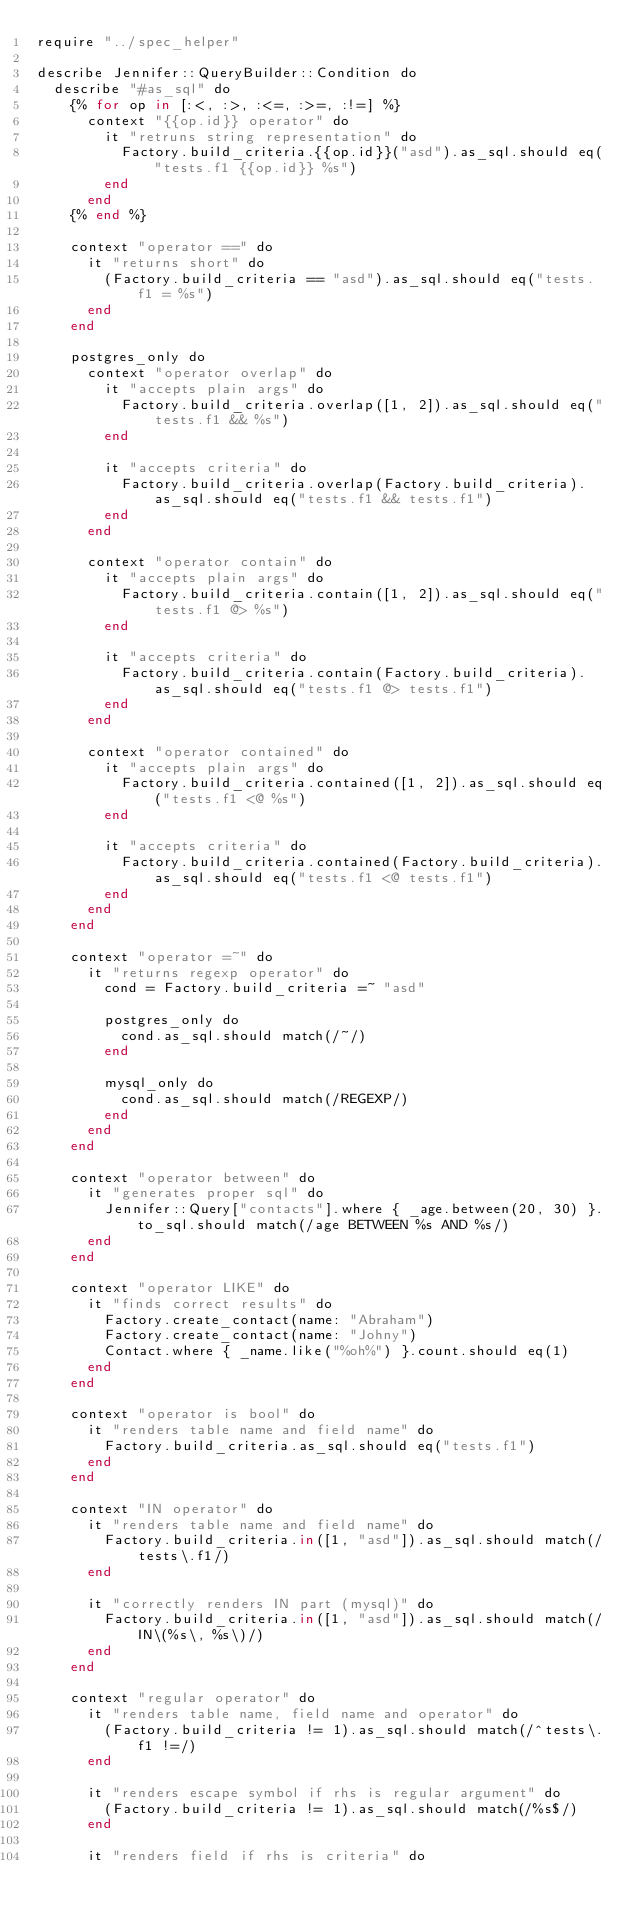<code> <loc_0><loc_0><loc_500><loc_500><_Crystal_>require "../spec_helper"

describe Jennifer::QueryBuilder::Condition do
  describe "#as_sql" do
    {% for op in [:<, :>, :<=, :>=, :!=] %}
      context "{{op.id}} operator" do
        it "retruns string representation" do
          Factory.build_criteria.{{op.id}}("asd").as_sql.should eq("tests.f1 {{op.id}} %s")
        end
      end
    {% end %}

    context "operator ==" do
      it "returns short" do
        (Factory.build_criteria == "asd").as_sql.should eq("tests.f1 = %s")
      end
    end

    postgres_only do
      context "operator overlap" do
        it "accepts plain args" do
          Factory.build_criteria.overlap([1, 2]).as_sql.should eq("tests.f1 && %s")
        end

        it "accepts criteria" do
          Factory.build_criteria.overlap(Factory.build_criteria).as_sql.should eq("tests.f1 && tests.f1")
        end
      end

      context "operator contain" do
        it "accepts plain args" do
          Factory.build_criteria.contain([1, 2]).as_sql.should eq("tests.f1 @> %s")
        end

        it "accepts criteria" do
          Factory.build_criteria.contain(Factory.build_criteria).as_sql.should eq("tests.f1 @> tests.f1")
        end
      end

      context "operator contained" do
        it "accepts plain args" do
          Factory.build_criteria.contained([1, 2]).as_sql.should eq("tests.f1 <@ %s")
        end

        it "accepts criteria" do
          Factory.build_criteria.contained(Factory.build_criteria).as_sql.should eq("tests.f1 <@ tests.f1")
        end
      end
    end

    context "operator =~" do
      it "returns regexp operator" do
        cond = Factory.build_criteria =~ "asd"

        postgres_only do
          cond.as_sql.should match(/~/)
        end

        mysql_only do
          cond.as_sql.should match(/REGEXP/)
        end
      end
    end

    context "operator between" do
      it "generates proper sql" do
        Jennifer::Query["contacts"].where { _age.between(20, 30) }.to_sql.should match(/age BETWEEN %s AND %s/)
      end
    end

    context "operator LIKE" do
      it "finds correct results" do
        Factory.create_contact(name: "Abraham")
        Factory.create_contact(name: "Johny")
        Contact.where { _name.like("%oh%") }.count.should eq(1)
      end
    end

    context "operator is bool" do
      it "renders table name and field name" do
        Factory.build_criteria.as_sql.should eq("tests.f1")
      end
    end

    context "IN operator" do
      it "renders table name and field name" do
        Factory.build_criteria.in([1, "asd"]).as_sql.should match(/tests\.f1/)
      end

      it "correctly renders IN part (mysql)" do
        Factory.build_criteria.in([1, "asd"]).as_sql.should match(/IN\(%s\, %s\)/)
      end
    end

    context "regular operator" do
      it "renders table name, field name and operator" do
        (Factory.build_criteria != 1).as_sql.should match(/^tests\.f1 !=/)
      end

      it "renders escape symbol if rhs is regular argument" do
        (Factory.build_criteria != 1).as_sql.should match(/%s$/)
      end

      it "renders field if rhs is criteria" do</code> 